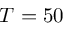Convert formula to latex. <formula><loc_0><loc_0><loc_500><loc_500>T = 5 0</formula> 